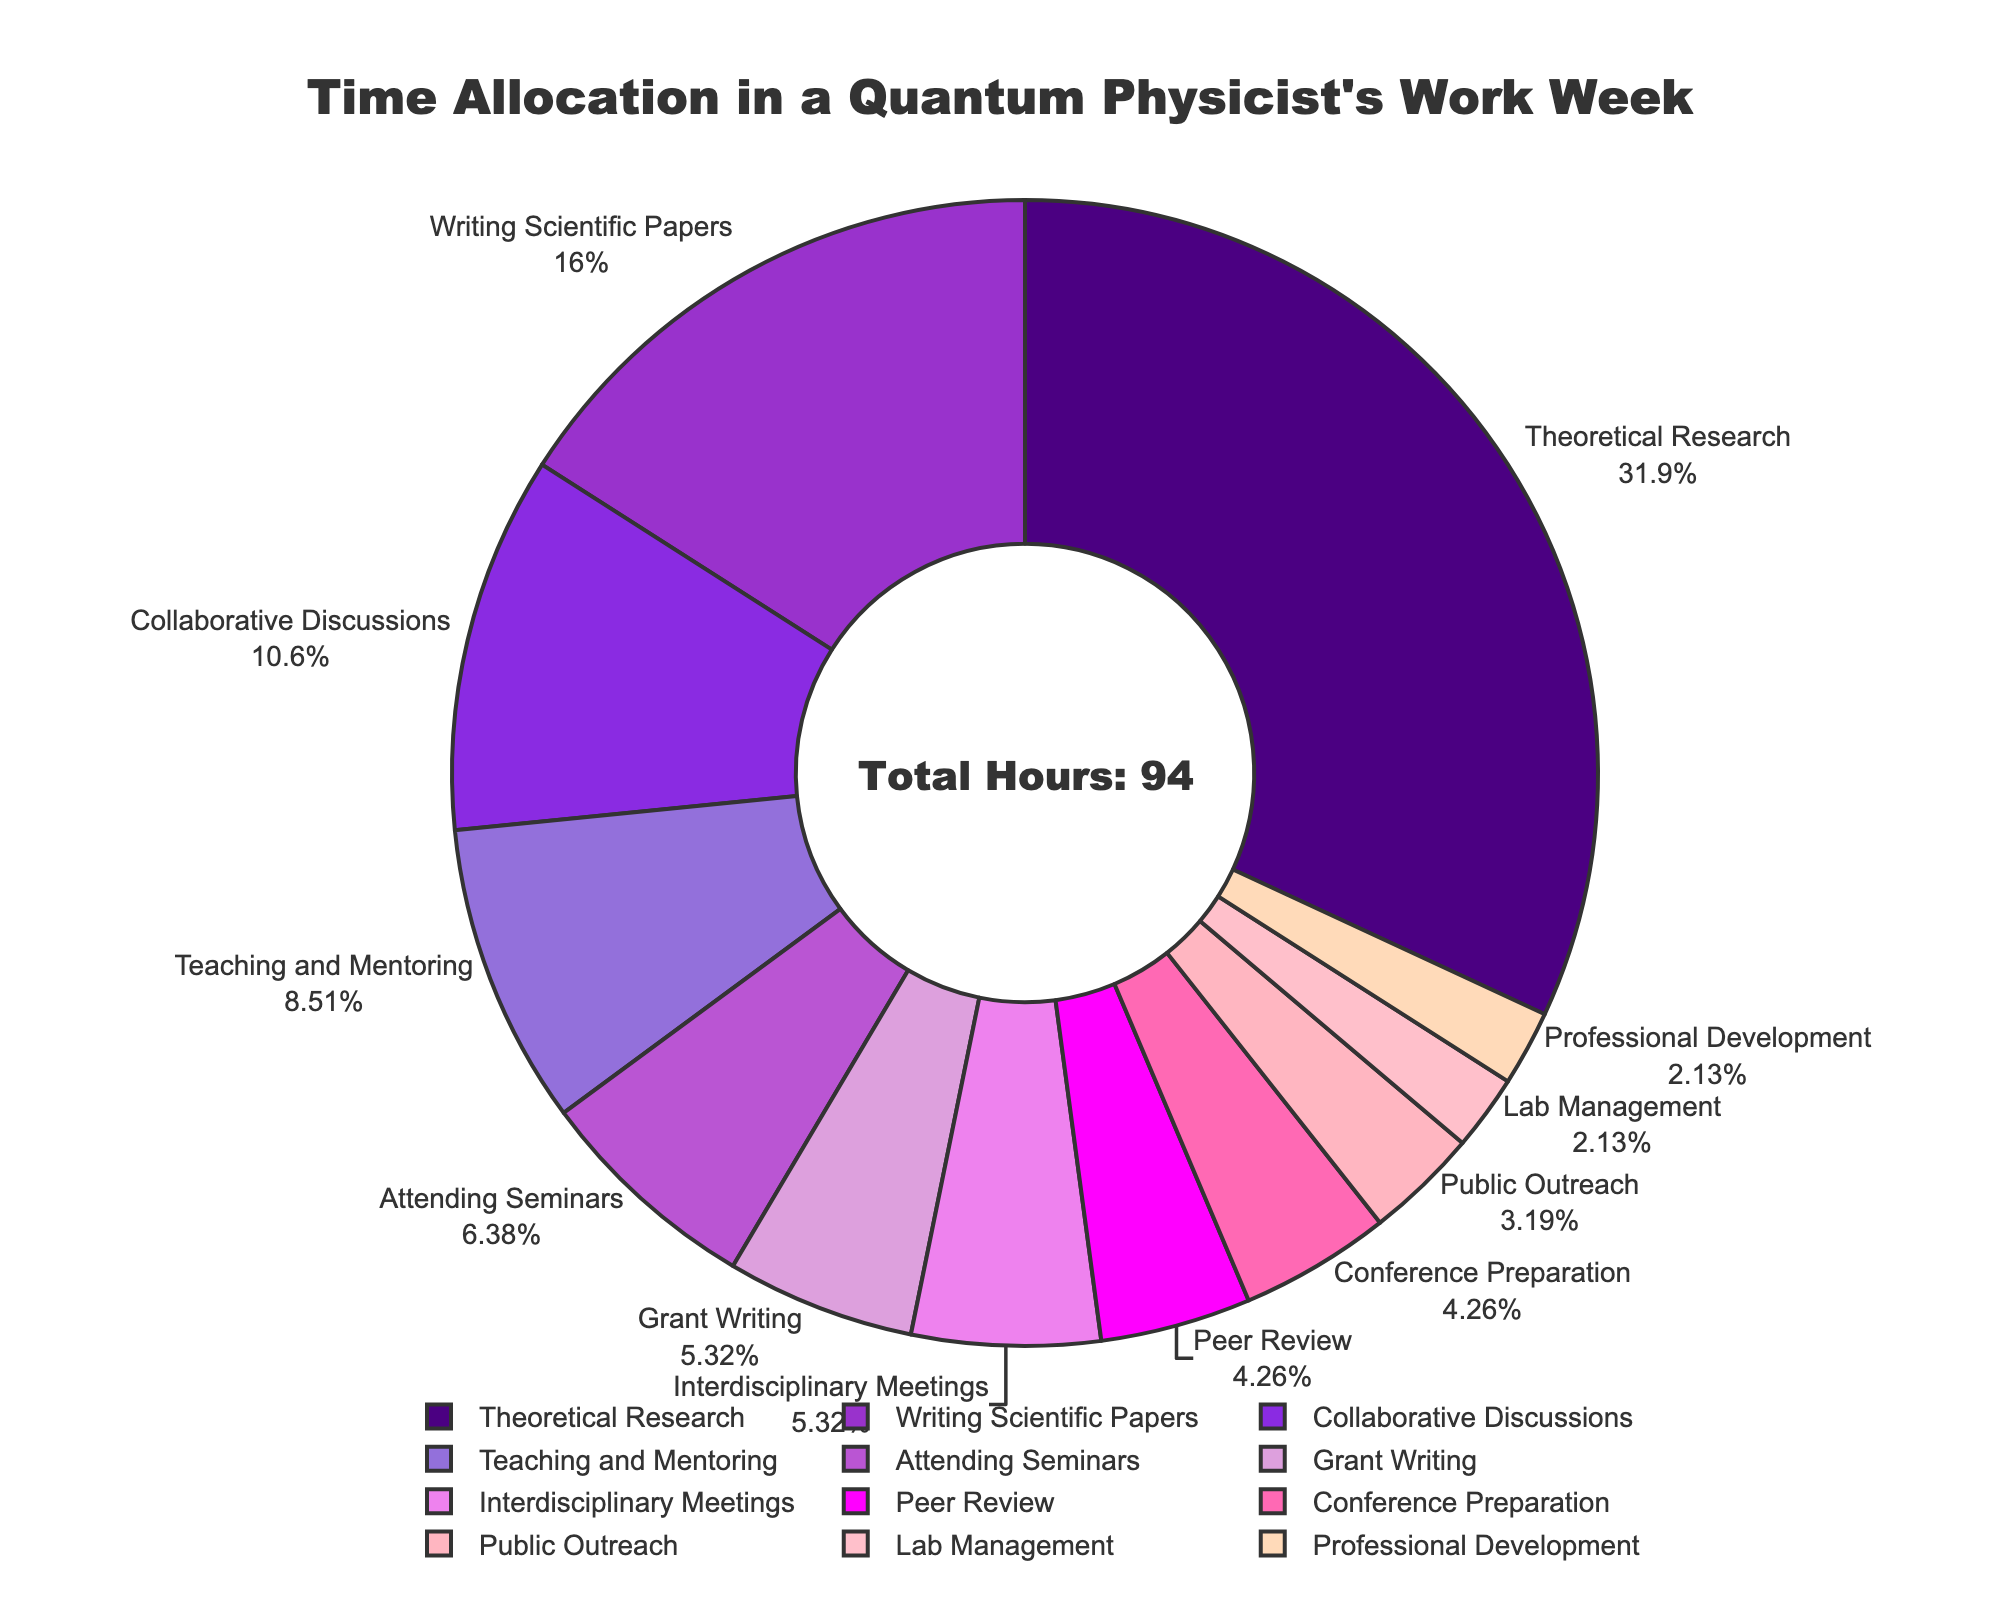What's the total time spent on activities involving interactions with others (Collaborative Discussions, Teaching and Mentoring, Attending Seminars, Interdisciplinary Meetings, Public Outreach)? To find this, we need to sum the hours spent on these activities: Collaborative Discussions (10), Teaching and Mentoring (8), Attending Seminars (6), Interdisciplinary Meetings (5), and Public Outreach (3). The sum is 10 + 8 + 6 + 5 + 3 = 32 hours.
Answer: 32 hours Which single activity takes up the most time in a quantum physicist's work week? From the pie chart, we can see that Theoretical Research occupies the largest segment with 30 hours.
Answer: Theoretical Research How much more time is spent on Theoretical Research compared to Grant Writing? Theoretical Research takes 30 hours, and Grant Writing takes 5 hours. The difference is 30 - 5 = 25 hours.
Answer: 25 hours What percentage of the total work week is spent on Theoretical Research? The total hours of activities are 94 hours. Theoretical Research takes up 30 hours. The percentage is calculated as (30/94) * 100 ≈ 31.91%.
Answer: 31.91% What is the combined time spent on Writing Scientific Papers and Peer Review? Writing Scientific Papers takes 15 hours and Peer Review takes 4 hours. The combined time is 15 + 4 = 19 hours.
Answer: 19 hours Is more time spent on Public Outreach or Professional Development? From the pie chart, Public Outreach takes 3 hours, and Professional Development takes 2 hours. Therefore, more time is spent on Public Outreach.
Answer: Public Outreach What’s the ratio of hours spent on Teaching and Mentoring to Attending Seminars? Teaching and Mentoring takes 8 hours, and Attending Seminars takes 6 hours. The ratio is 8:6, which can be simplified to 4:3.
Answer: 4:3 Which activities together occupy exactly 10 hours in the week? According to the chart, Collaborative Discussions alone occupy 10 hours.
Answer: Collaborative Discussions What's the combined percentage of time spent on Lab Management and Conference Preparation? The total hours are 94. Lab Management takes 2 hours and Conference Preparation takes 4 hours. Their combined percentage is ((2+4)/94) * 100 ≈ 6.38%.
Answer: 6.38% 